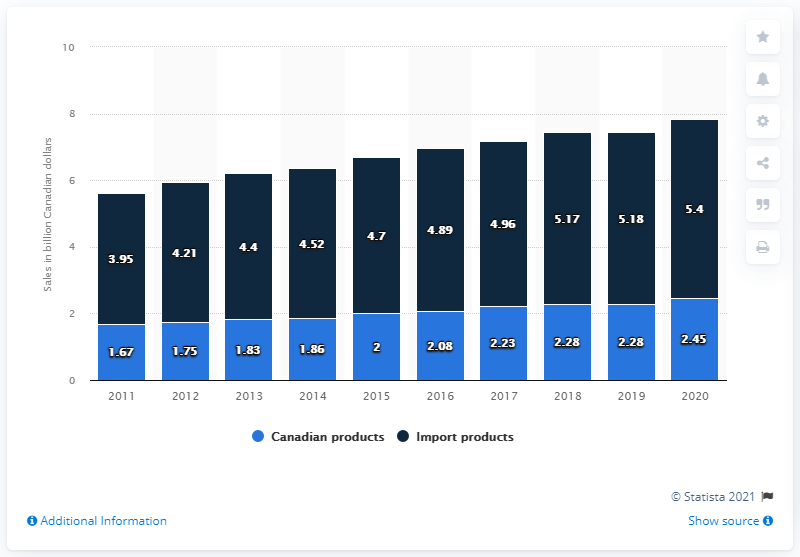Identify some key points in this picture. According to data from the Canadian wine industry, the sales value of Canadian wine in Canada during the fiscal year ending March 31, 2020, was approximately CAD 2.45 billion. During the fiscal year ending March 31, 2020, the importation of wine in Canada was 5.4 million. The average wine dollar sales of Canadian products increased from 2018 to 2019, reaching 2.28 billion Canadian dollars. The smallest bar is blue in color. 